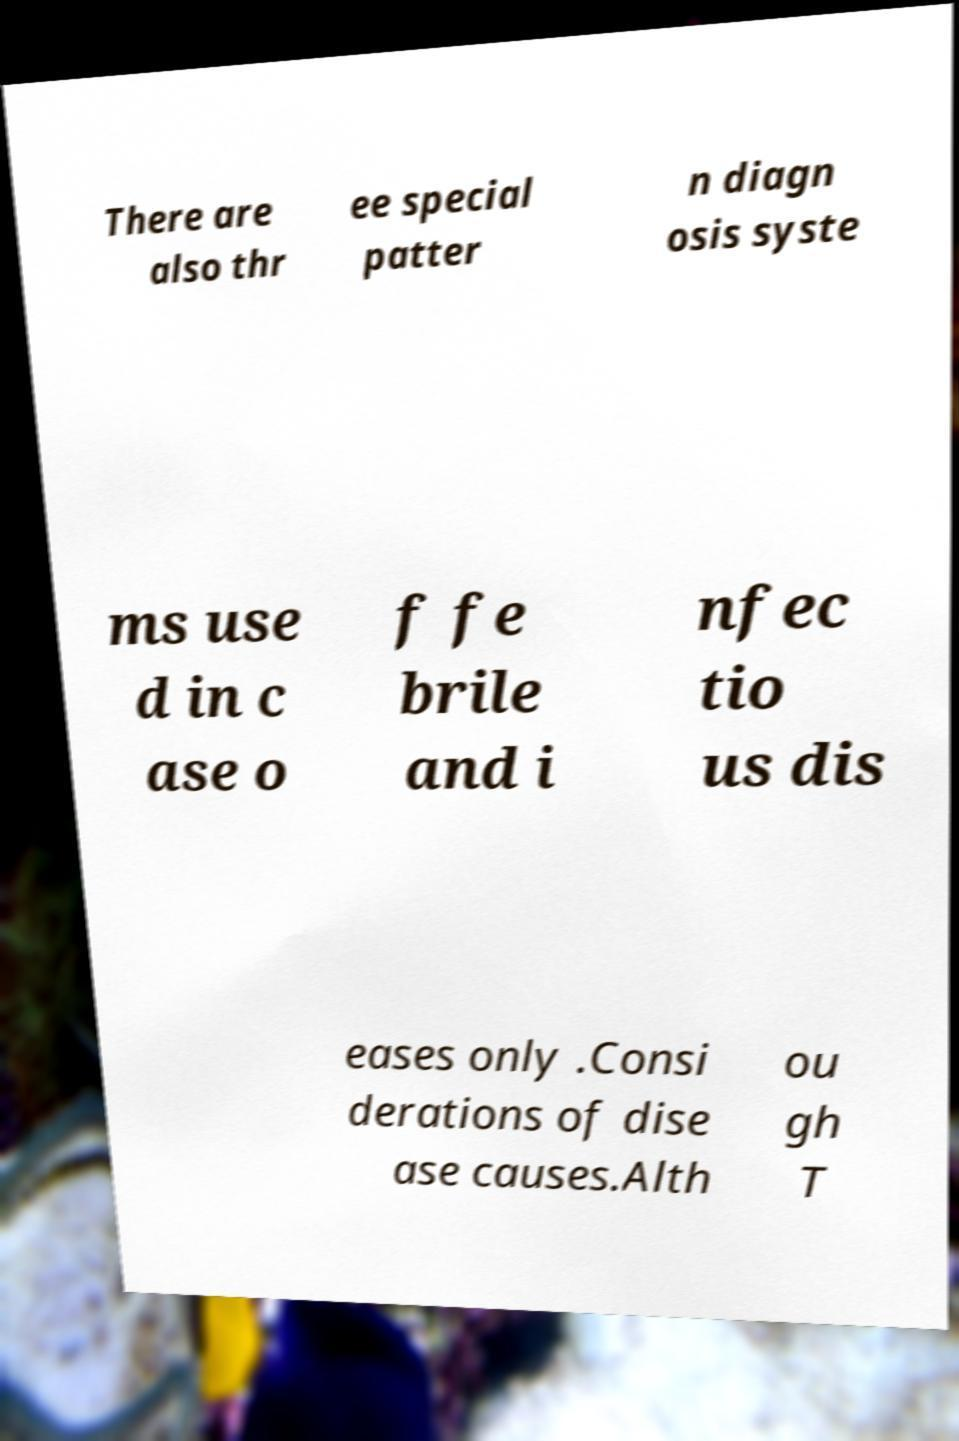I need the written content from this picture converted into text. Can you do that? There are also thr ee special patter n diagn osis syste ms use d in c ase o f fe brile and i nfec tio us dis eases only .Consi derations of dise ase causes.Alth ou gh T 